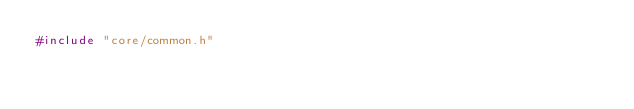Convert code to text. <code><loc_0><loc_0><loc_500><loc_500><_C_>#include "core/common.h"</code> 